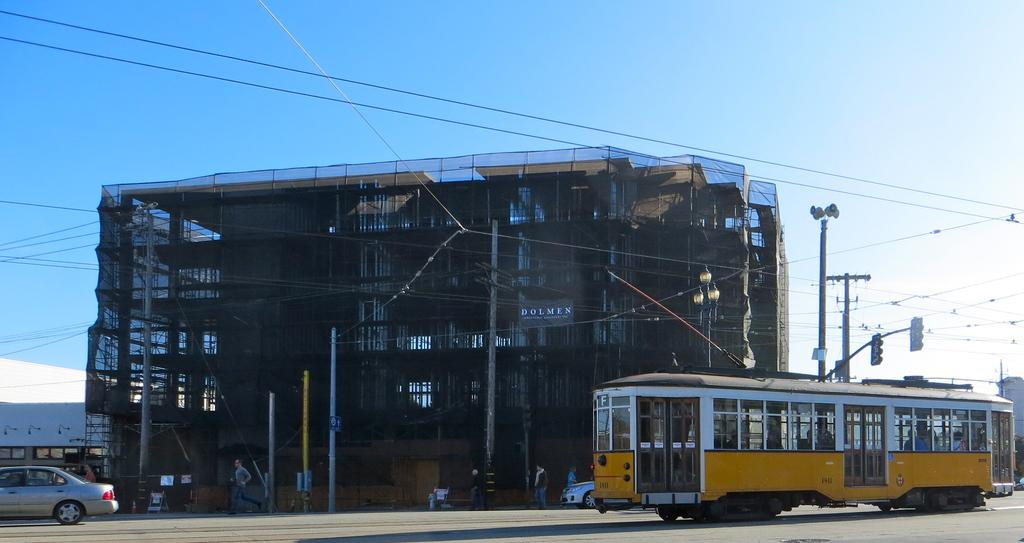What type of structure is present in the image? There is a building in the image. What mode of transportation can be seen at the bottom of the image? There is a car at the bottom of the image. What other mode of transportation is visible in the image? There is a bus on the right side of the image. What is visible at the top of the image? The sky is visible at the top of the image. How many trees are present in the image? There are no trees visible in the image. What type of art can be seen hanging on the walls of the building? There is no art visible in the image, as it only shows a building, a car, a bus, and the sky. 